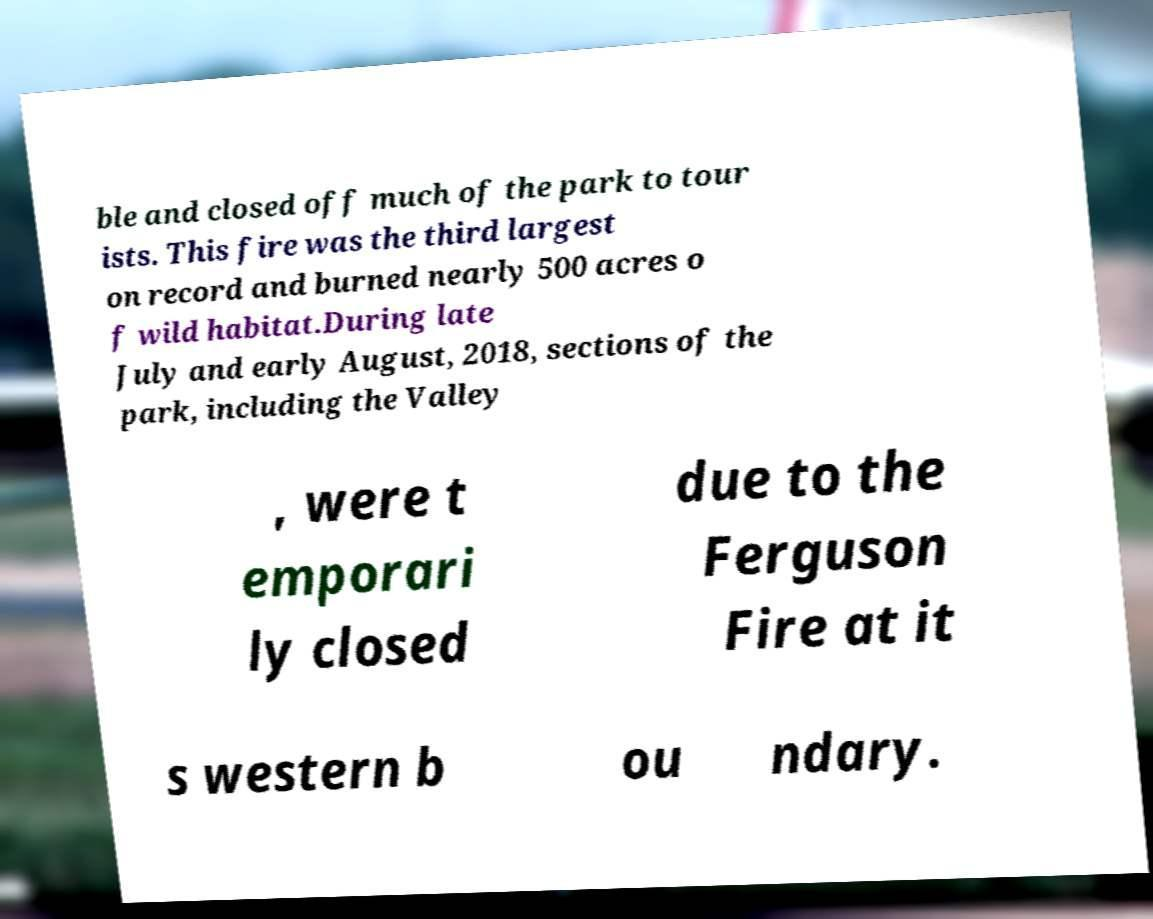Could you extract and type out the text from this image? ble and closed off much of the park to tour ists. This fire was the third largest on record and burned nearly 500 acres o f wild habitat.During late July and early August, 2018, sections of the park, including the Valley , were t emporari ly closed due to the Ferguson Fire at it s western b ou ndary. 